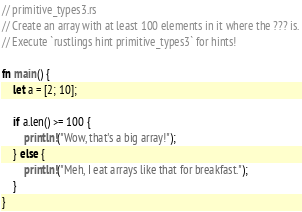<code> <loc_0><loc_0><loc_500><loc_500><_Rust_>// primitive_types3.rs
// Create an array with at least 100 elements in it where the ??? is.
// Execute `rustlings hint primitive_types3` for hints!

fn main() {
    let a = [2; 10];

    if a.len() >= 100 {
        println!("Wow, that's a big array!");
    } else {
        println!("Meh, I eat arrays like that for breakfast.");
    }
}
</code> 